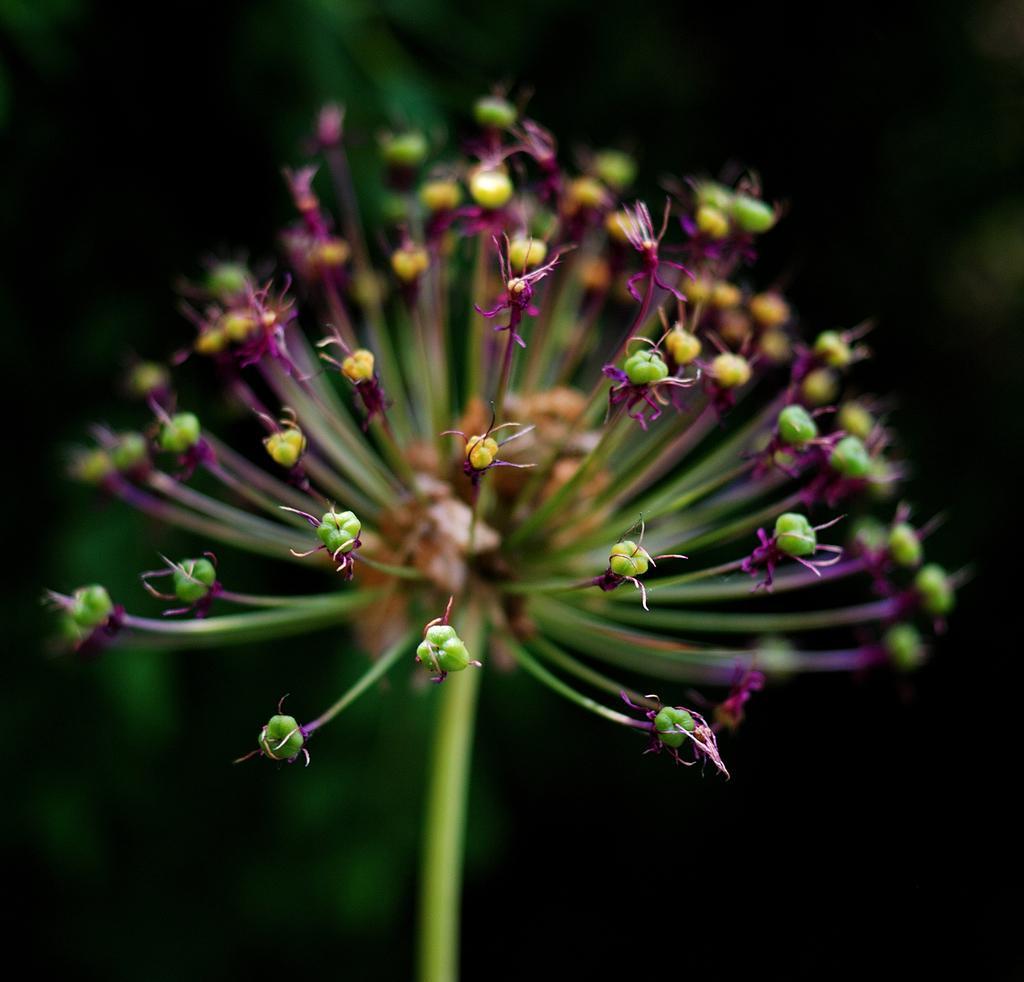Describe this image in one or two sentences. Here we can see buds. Background it is dark. 